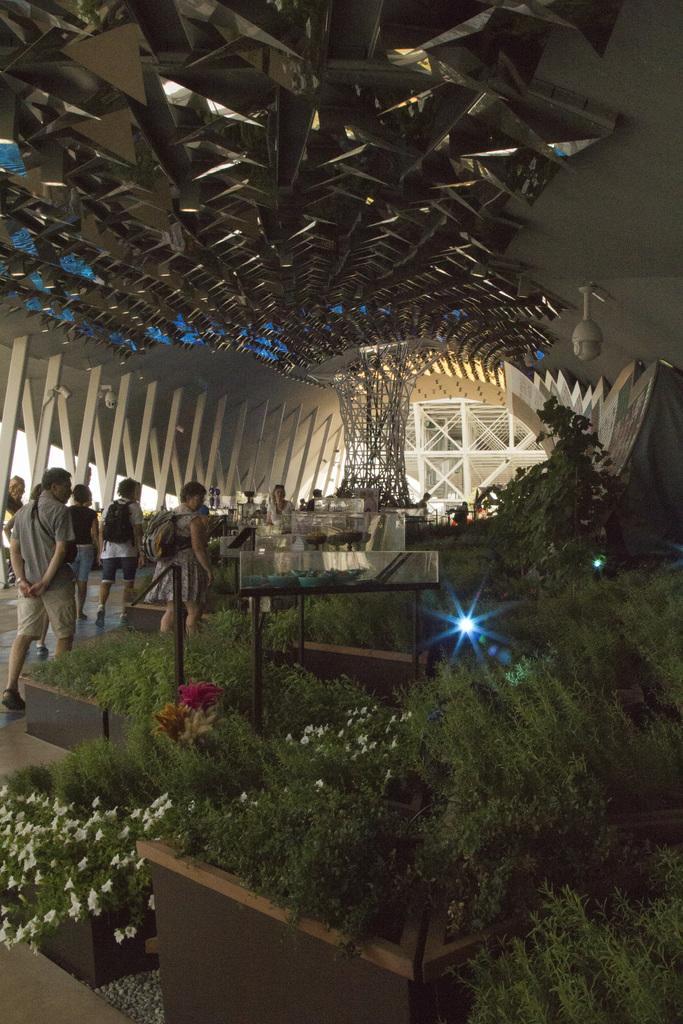Please provide a concise description of this image. In this image, on the left there are many people. In the middle there are plants, lights, people, architecture, Cc-camera and a wall. 